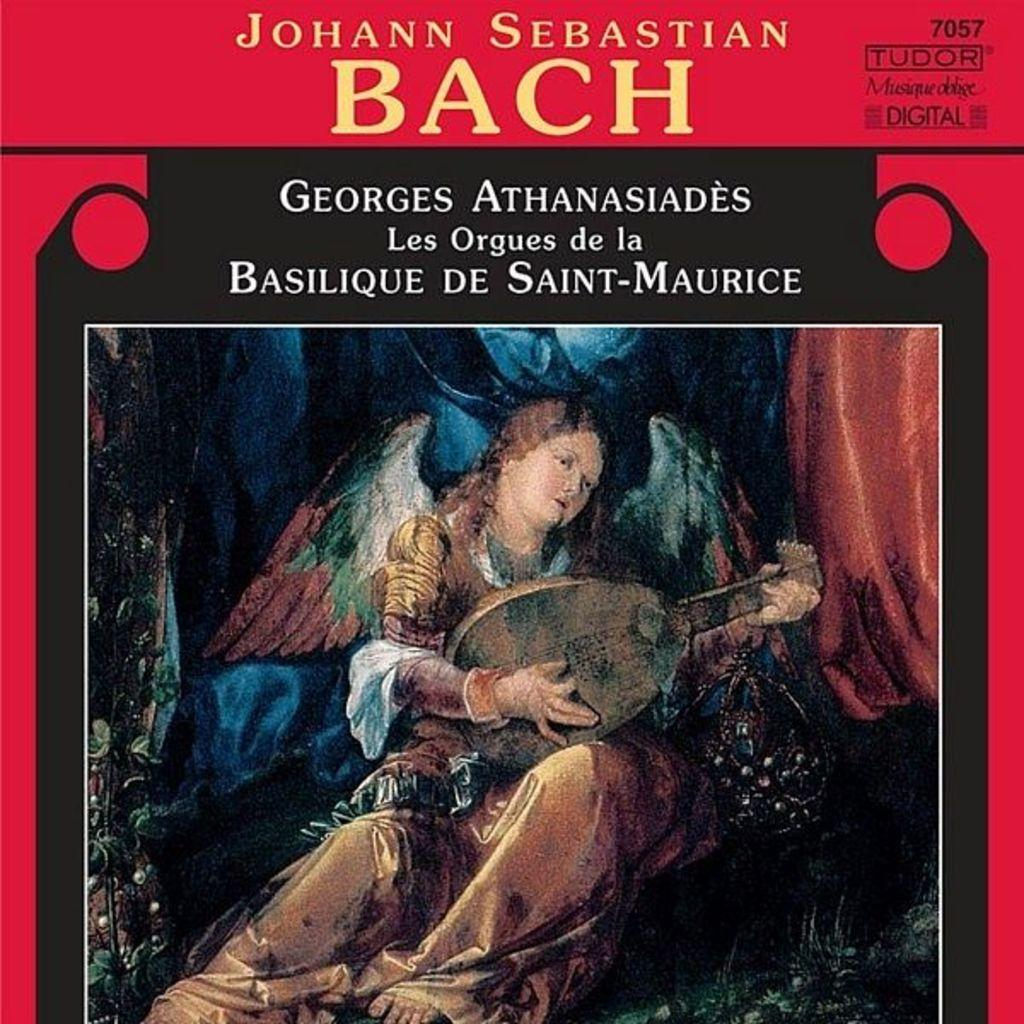<image>
Relay a brief, clear account of the picture shown. the name Bach is on the album cover 